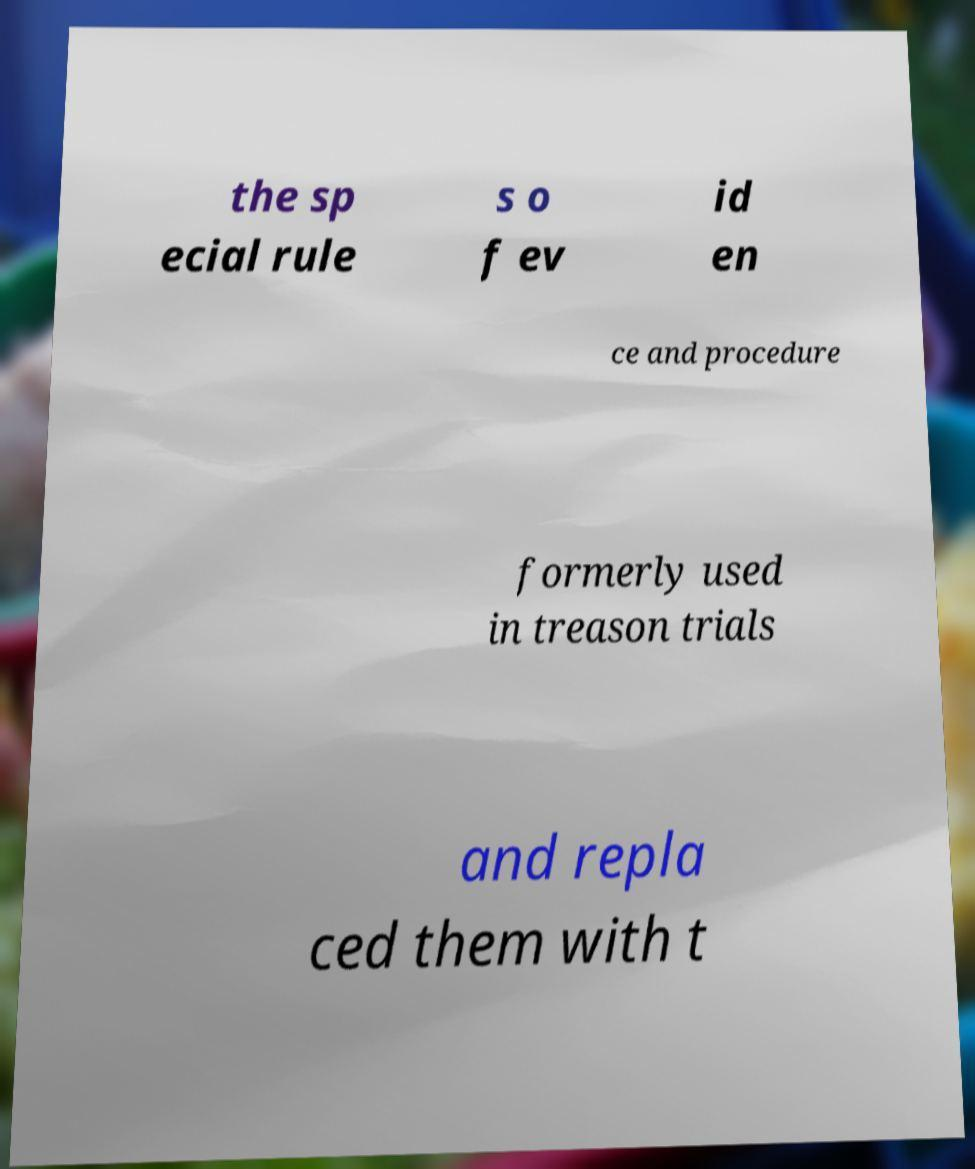I need the written content from this picture converted into text. Can you do that? the sp ecial rule s o f ev id en ce and procedure formerly used in treason trials and repla ced them with t 